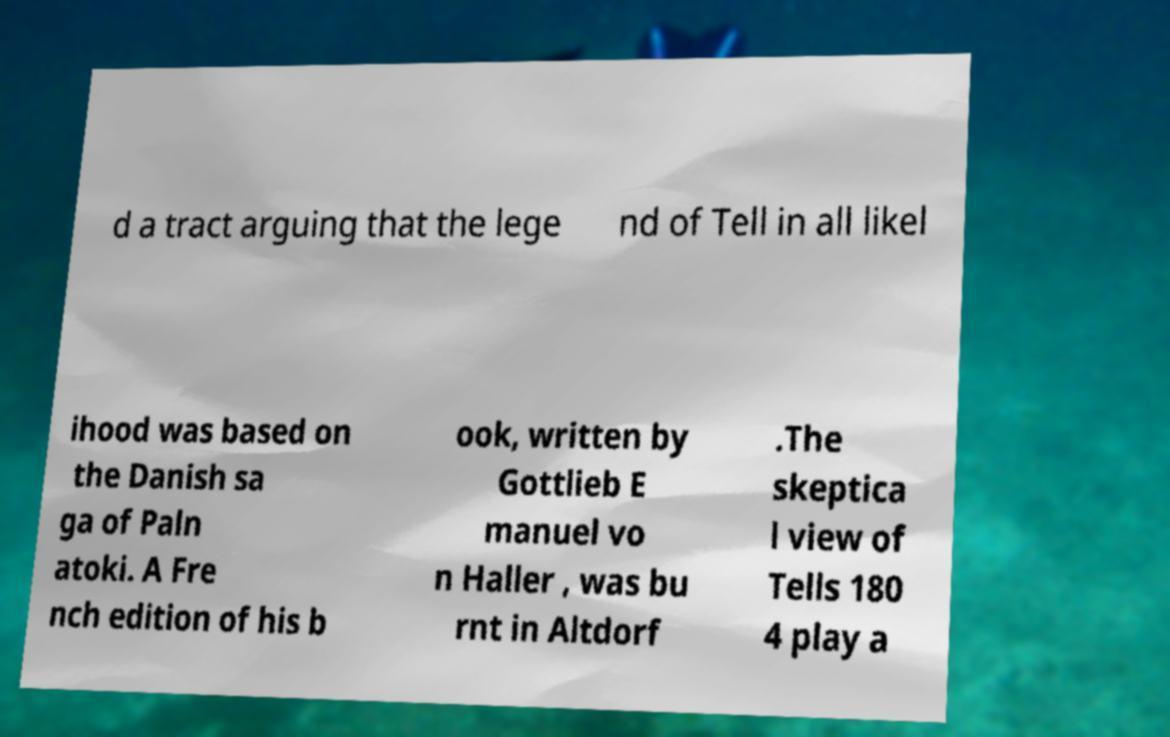Could you extract and type out the text from this image? d a tract arguing that the lege nd of Tell in all likel ihood was based on the Danish sa ga of Paln atoki. A Fre nch edition of his b ook, written by Gottlieb E manuel vo n Haller , was bu rnt in Altdorf .The skeptica l view of Tells 180 4 play a 